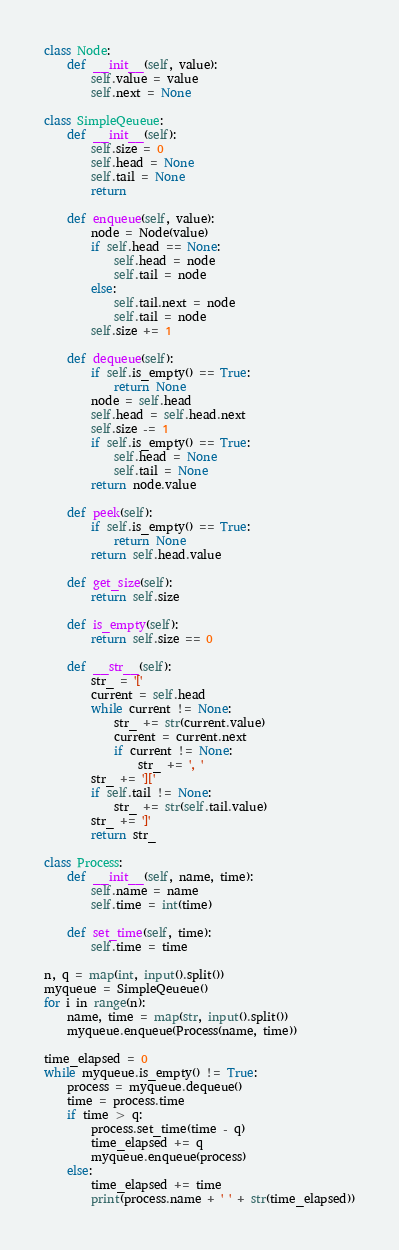Convert code to text. <code><loc_0><loc_0><loc_500><loc_500><_Python_>
class Node:
	def __init__(self, value):
		self.value = value
		self.next = None

class SimpleQeueue:
	def __init__(self):
		self.size = 0
		self.head = None
		self.tail = None
		return

	def enqueue(self, value):
		node = Node(value)
		if self.head == None:
			self.head = node
			self.tail = node
		else:
			self.tail.next = node
			self.tail = node
		self.size += 1

	def dequeue(self):
		if self.is_empty() == True:
			return None
		node = self.head
		self.head = self.head.next
		self.size -= 1
		if self.is_empty() == True:
			self.head = None
			self.tail = None
		return node.value

	def peek(self):
		if self.is_empty() == True:
			return None
		return self.head.value

	def get_size(self):
		return self.size

	def is_empty(self):
		return self.size == 0

	def __str__(self):
		str_ = '['
		current = self.head
		while current != None:
			str_ += str(current.value)
			current = current.next
			if current != None:
				str_ += ', '
		str_ += ']['
		if self.tail != None:
			str_ += str(self.tail.value)
		str_ += ']'
		return str_

class Process:
	def __init__(self, name, time):
		self.name = name
		self.time = int(time)

	def set_time(self, time):
		self.time = time

n, q = map(int, input().split())
myqueue = SimpleQeueue()
for i in range(n):
	name, time = map(str, input().split())
	myqueue.enqueue(Process(name, time))

time_elapsed = 0
while myqueue.is_empty() != True:
	process = myqueue.dequeue()
	time = process.time
	if time > q:
		process.set_time(time - q)
		time_elapsed += q
		myqueue.enqueue(process)
	else:
		time_elapsed += time
		print(process.name + ' ' + str(time_elapsed))

</code> 